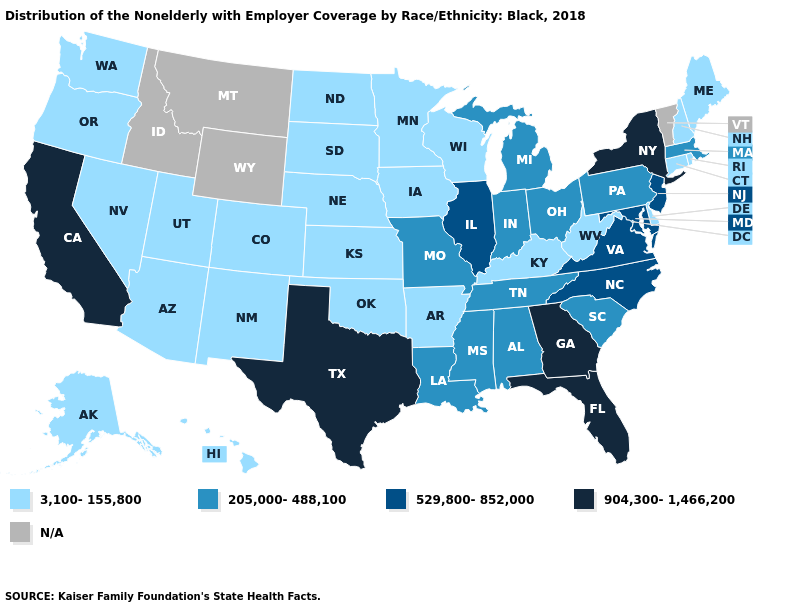Which states have the lowest value in the Northeast?
Quick response, please. Connecticut, Maine, New Hampshire, Rhode Island. Name the states that have a value in the range 205,000-488,100?
Short answer required. Alabama, Indiana, Louisiana, Massachusetts, Michigan, Mississippi, Missouri, Ohio, Pennsylvania, South Carolina, Tennessee. Among the states that border Arizona , does New Mexico have the highest value?
Short answer required. No. Does the map have missing data?
Keep it brief. Yes. Among the states that border South Carolina , which have the lowest value?
Give a very brief answer. North Carolina. Name the states that have a value in the range 529,800-852,000?
Give a very brief answer. Illinois, Maryland, New Jersey, North Carolina, Virginia. Among the states that border Minnesota , which have the highest value?
Be succinct. Iowa, North Dakota, South Dakota, Wisconsin. Name the states that have a value in the range 904,300-1,466,200?
Concise answer only. California, Florida, Georgia, New York, Texas. What is the highest value in the Northeast ?
Keep it brief. 904,300-1,466,200. Among the states that border Georgia , which have the lowest value?
Be succinct. Alabama, South Carolina, Tennessee. Name the states that have a value in the range 529,800-852,000?
Keep it brief. Illinois, Maryland, New Jersey, North Carolina, Virginia. Which states have the lowest value in the Northeast?
Keep it brief. Connecticut, Maine, New Hampshire, Rhode Island. Among the states that border Connecticut , which have the highest value?
Concise answer only. New York. Name the states that have a value in the range 904,300-1,466,200?
Short answer required. California, Florida, Georgia, New York, Texas. What is the value of Colorado?
Keep it brief. 3,100-155,800. 